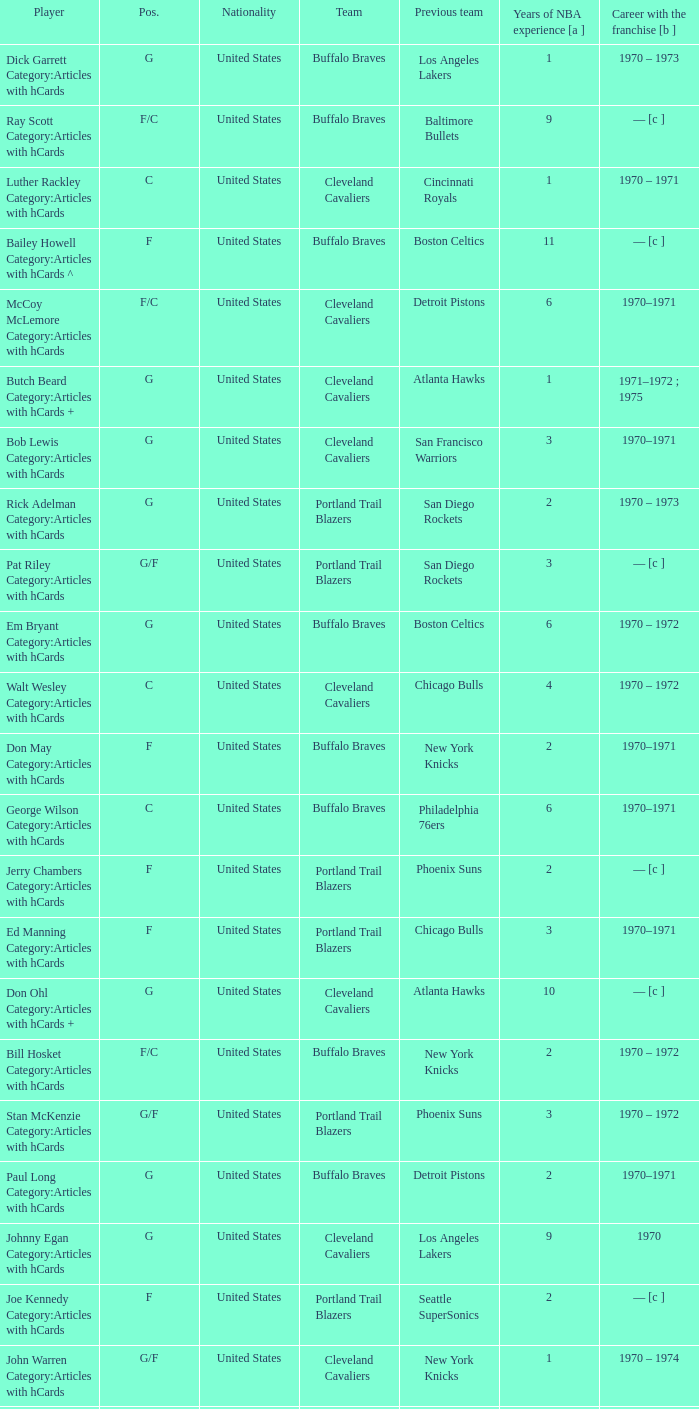How many years of NBA experience does the player who plays position g for the Portland Trail Blazers? 2.0. Parse the table in full. {'header': ['Player', 'Pos.', 'Nationality', 'Team', 'Previous team', 'Years of NBA experience [a ]', 'Career with the franchise [b ]'], 'rows': [['Dick Garrett Category:Articles with hCards', 'G', 'United States', 'Buffalo Braves', 'Los Angeles Lakers', '1', '1970 – 1973'], ['Ray Scott Category:Articles with hCards', 'F/C', 'United States', 'Buffalo Braves', 'Baltimore Bullets', '9', '— [c ]'], ['Luther Rackley Category:Articles with hCards', 'C', 'United States', 'Cleveland Cavaliers', 'Cincinnati Royals', '1', '1970 – 1971'], ['Bailey Howell Category:Articles with hCards ^', 'F', 'United States', 'Buffalo Braves', 'Boston Celtics', '11', '— [c ]'], ['McCoy McLemore Category:Articles with hCards', 'F/C', 'United States', 'Cleveland Cavaliers', 'Detroit Pistons', '6', '1970–1971'], ['Butch Beard Category:Articles with hCards +', 'G', 'United States', 'Cleveland Cavaliers', 'Atlanta Hawks', '1', '1971–1972 ; 1975'], ['Bob Lewis Category:Articles with hCards', 'G', 'United States', 'Cleveland Cavaliers', 'San Francisco Warriors', '3', '1970–1971'], ['Rick Adelman Category:Articles with hCards', 'G', 'United States', 'Portland Trail Blazers', 'San Diego Rockets', '2', '1970 – 1973'], ['Pat Riley Category:Articles with hCards', 'G/F', 'United States', 'Portland Trail Blazers', 'San Diego Rockets', '3', '— [c ]'], ['Em Bryant Category:Articles with hCards', 'G', 'United States', 'Buffalo Braves', 'Boston Celtics', '6', '1970 – 1972'], ['Walt Wesley Category:Articles with hCards', 'C', 'United States', 'Cleveland Cavaliers', 'Chicago Bulls', '4', '1970 – 1972'], ['Don May Category:Articles with hCards', 'F', 'United States', 'Buffalo Braves', 'New York Knicks', '2', '1970–1971'], ['George Wilson Category:Articles with hCards', 'C', 'United States', 'Buffalo Braves', 'Philadelphia 76ers', '6', '1970–1971'], ['Jerry Chambers Category:Articles with hCards', 'F', 'United States', 'Portland Trail Blazers', 'Phoenix Suns', '2', '— [c ]'], ['Ed Manning Category:Articles with hCards', 'F', 'United States', 'Portland Trail Blazers', 'Chicago Bulls', '3', '1970–1971'], ['Don Ohl Category:Articles with hCards +', 'G', 'United States', 'Cleveland Cavaliers', 'Atlanta Hawks', '10', '— [c ]'], ['Bill Hosket Category:Articles with hCards', 'F/C', 'United States', 'Buffalo Braves', 'New York Knicks', '2', '1970 – 1972'], ['Stan McKenzie Category:Articles with hCards', 'G/F', 'United States', 'Portland Trail Blazers', 'Phoenix Suns', '3', '1970 – 1972'], ['Paul Long Category:Articles with hCards', 'G', 'United States', 'Buffalo Braves', 'Detroit Pistons', '2', '1970–1971'], ['Johnny Egan Category:Articles with hCards', 'G', 'United States', 'Cleveland Cavaliers', 'Los Angeles Lakers', '9', '1970'], ['Joe Kennedy Category:Articles with hCards', 'F', 'United States', 'Portland Trail Blazers', 'Seattle SuperSonics', '2', '— [c ]'], ['John Warren Category:Articles with hCards', 'G/F', 'United States', 'Cleveland Cavaliers', 'New York Knicks', '1', '1970 – 1974'], ['Dale Schlueter Category:Articles with hCards', 'C', 'United States', 'Portland Trail Blazers', 'San Francisco Warriors', '2', '1970 – 1972 ; 1977–1978'], ['Bingo Smith Category:Articles with hCards', 'G/F', 'United States', 'Cleveland Cavaliers', 'San Diego Rockets', '1', '1970 – 1979'], ['Herm Gilliam Category:Articles with hCards', 'G/F', 'United States', 'Buffalo Braves', 'Cincinnati Royals', '1', '1970–1971'], ['Larry Siegfried Category:Articles with hCards', 'F', 'United States', 'Portland Trail Blazers', 'Boston Celtics', '7', '— [c ]'], ['LeRoy Ellis Category:Articles with hCards', 'F/C', 'United States', 'Portland Trail Blazers', 'Baltimore Bullets', '8', '1970–1971'], ['Mike Lynn Category:Articles with hCards', 'F', 'United States', 'Buffalo Braves', 'Los Angeles Lakers', '1', '1970'], ['Len Chappell Category:Articles with hCards +', 'F/C', 'United States', 'Cleveland Cavaliers', 'Milwaukee Bucks', '8', '1970'], ['Dorie Murrey Category:Articles with hCards', 'F/C', 'United States', 'Portland Trail Blazers', 'Seattle SuperSonics', '4', '1970'], ['Loy Petersen Category:Articles with hCards', 'G', 'United States', 'Cleveland Cavaliers', 'Chicago Bulls', '2', '— [c ]'], ['Freddie Crawford Category:Articles with hCards', 'G/F', 'United States', 'Buffalo Braves', 'Milwaukee Bucks', '4', '1970'], ['Fred Hetzel Category:Articles with hCards', 'F/C', 'United States', 'Portland Trail Blazers', 'Philadelphia 76ers', '5', '— [c ]']]} 